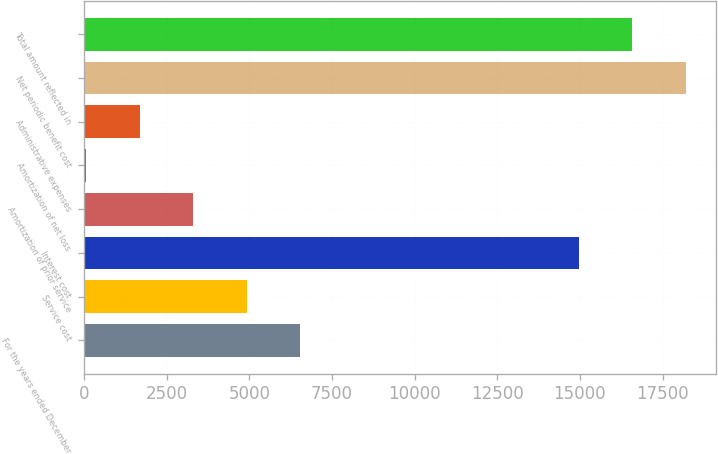Convert chart. <chart><loc_0><loc_0><loc_500><loc_500><bar_chart><fcel>For the years ended December<fcel>Service cost<fcel>Interest cost<fcel>Amortization of prior service<fcel>Amortization of net loss<fcel>Administrative expenses<fcel>Net periodic benefit cost<fcel>Total amount reflected in<nl><fcel>6529.8<fcel>4915.1<fcel>14967<fcel>3300.4<fcel>71<fcel>1685.7<fcel>18196.4<fcel>16581.7<nl></chart> 